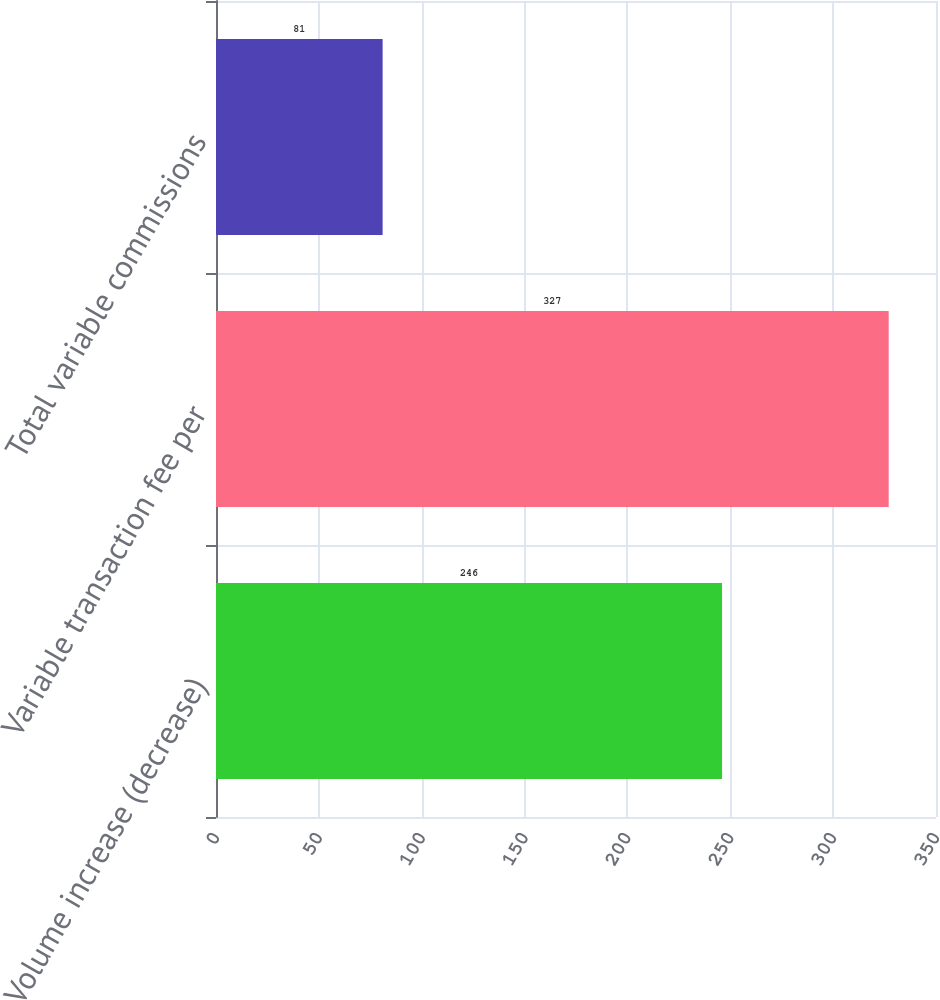Convert chart to OTSL. <chart><loc_0><loc_0><loc_500><loc_500><bar_chart><fcel>Volume increase (decrease)<fcel>Variable transaction fee per<fcel>Total variable commissions<nl><fcel>246<fcel>327<fcel>81<nl></chart> 